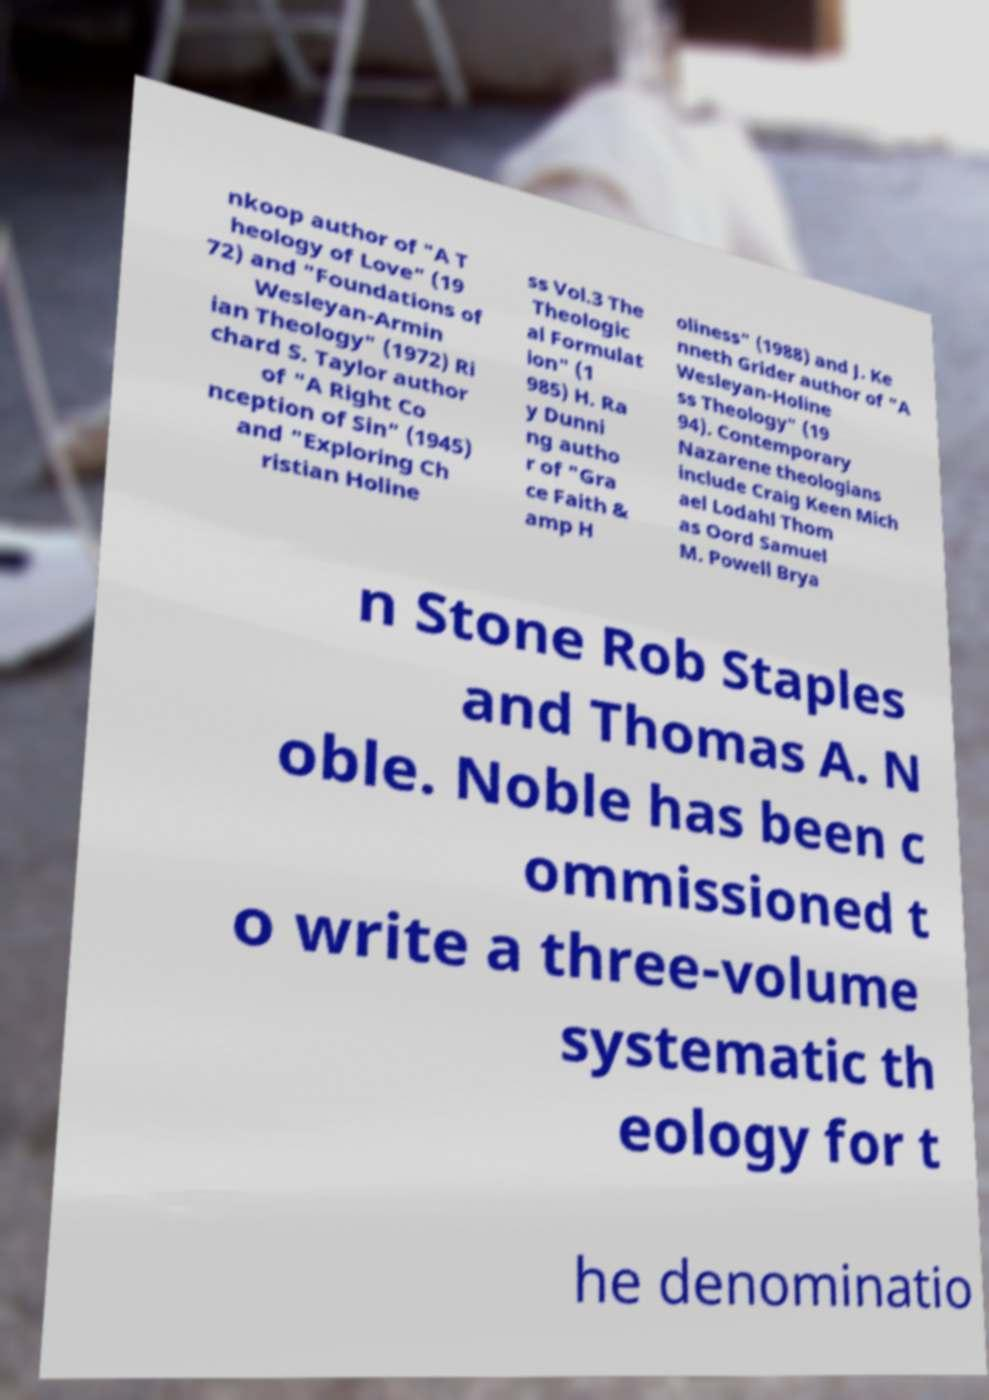Please read and relay the text visible in this image. What does it say? nkoop author of "A T heology of Love" (19 72) and "Foundations of Wesleyan-Armin ian Theology" (1972) Ri chard S. Taylor author of "A Right Co nception of Sin" (1945) and "Exploring Ch ristian Holine ss Vol.3 The Theologic al Formulat ion" (1 985) H. Ra y Dunni ng autho r of "Gra ce Faith & amp H oliness" (1988) and J. Ke nneth Grider author of "A Wesleyan-Holine ss Theology" (19 94). Contemporary Nazarene theologians include Craig Keen Mich ael Lodahl Thom as Oord Samuel M. Powell Brya n Stone Rob Staples and Thomas A. N oble. Noble has been c ommissioned t o write a three-volume systematic th eology for t he denominatio 